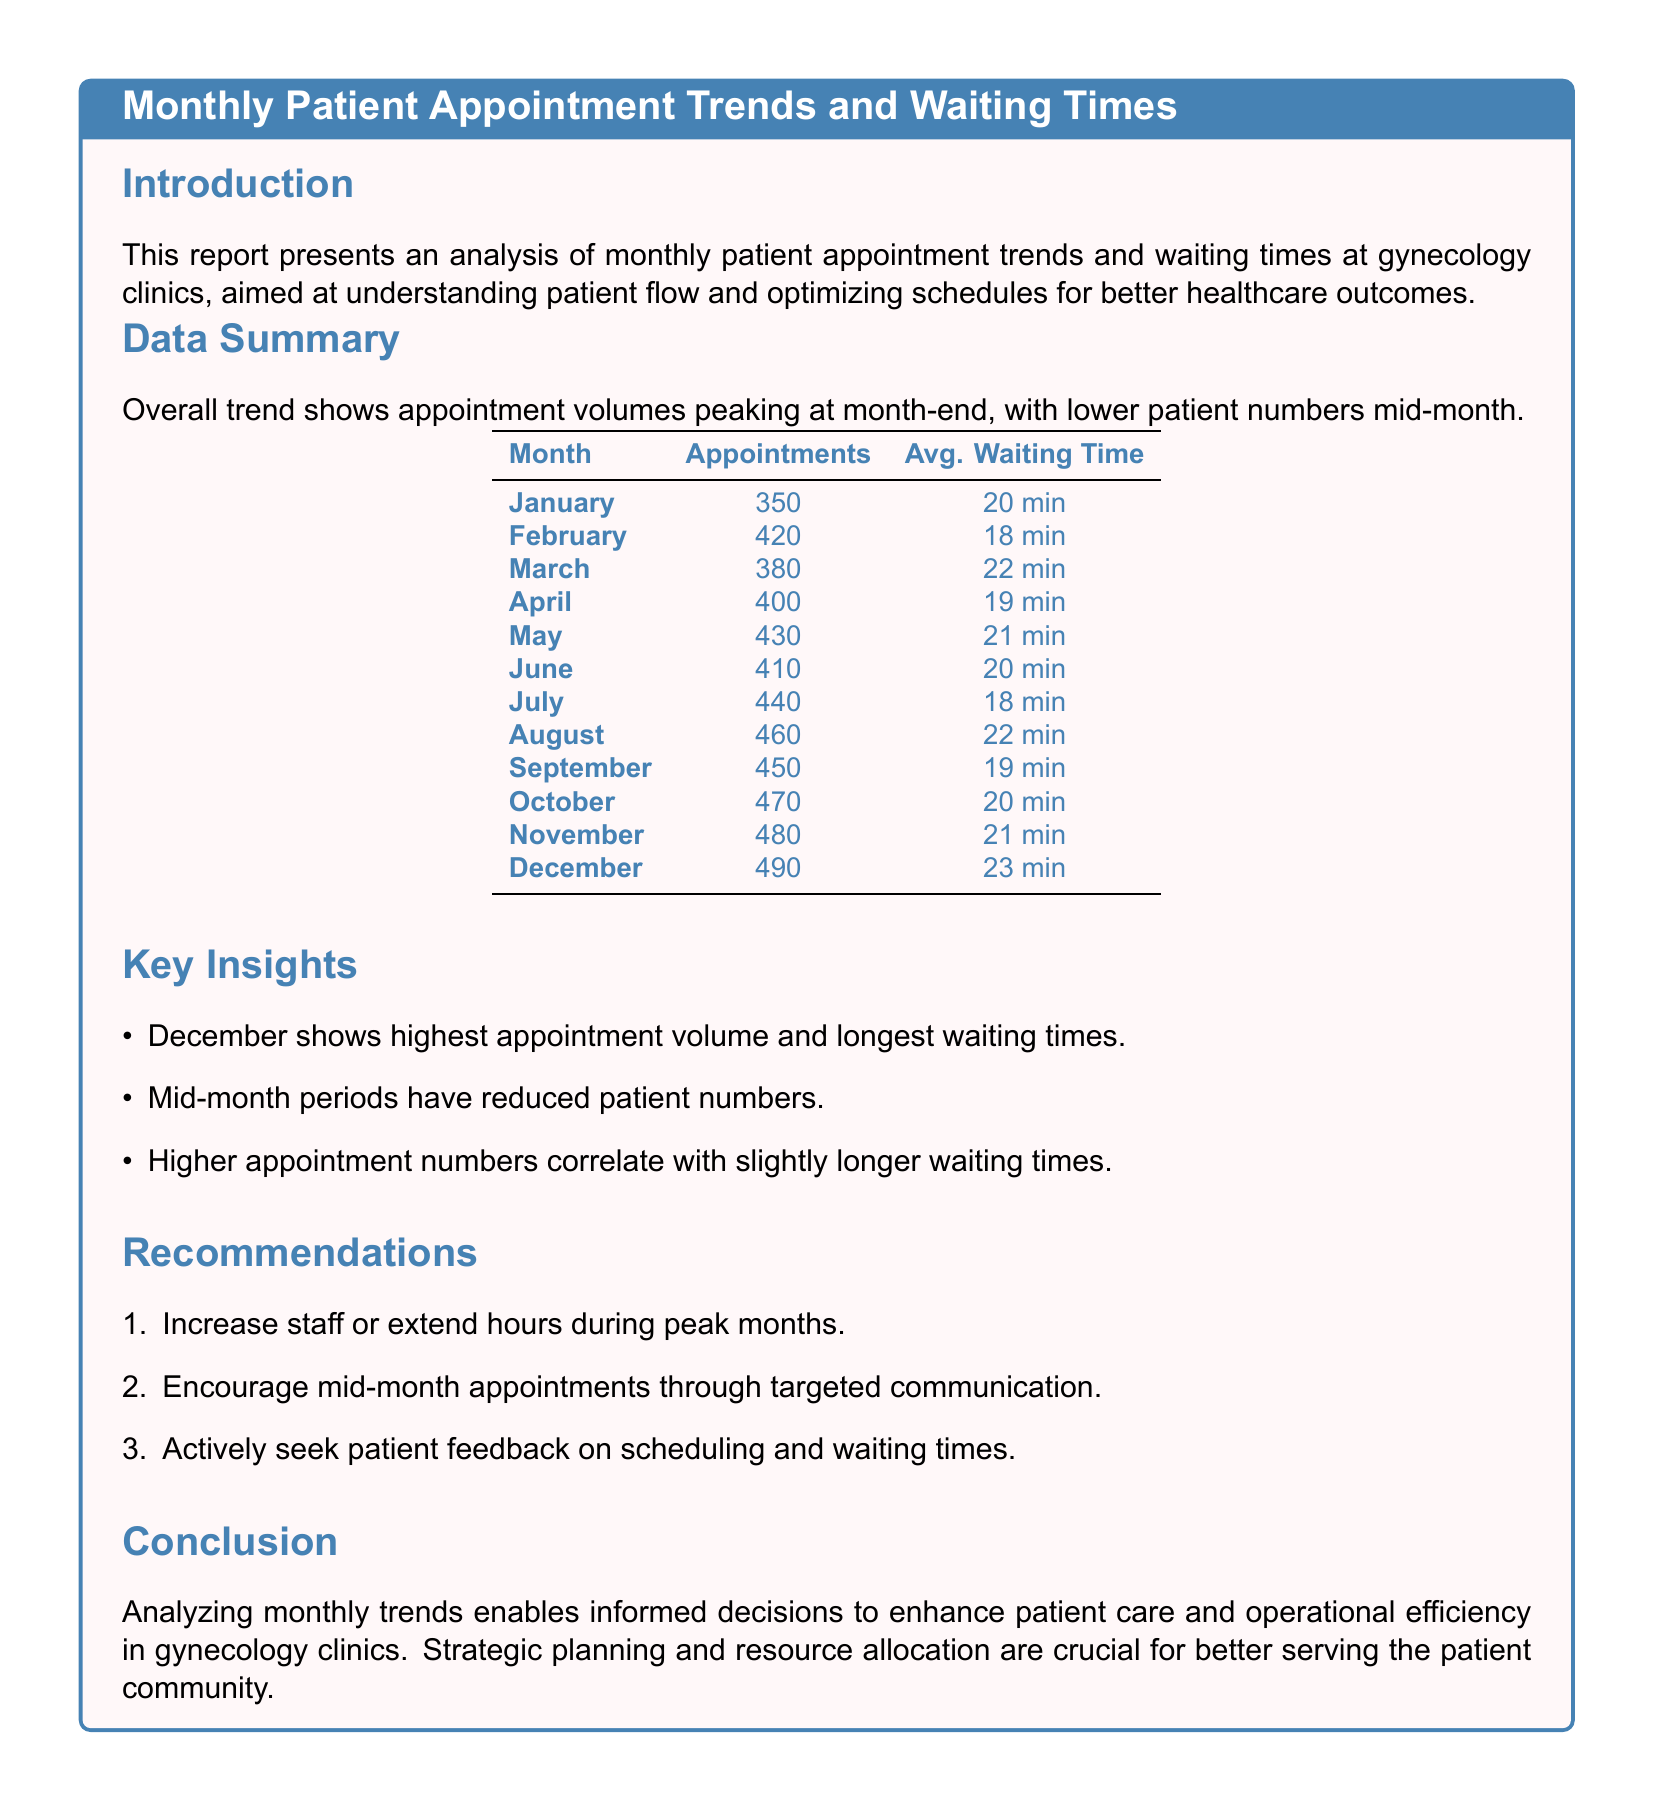What is the highest number of appointments recorded? The highest number of appointments recorded is found in the summary table for December, where it equals 490.
Answer: 490 What is the average waiting time in January? The average waiting time for January is specifically listed in the data summary section as 20 minutes.
Answer: 20 min Which month has the lowest average waiting time? By comparing the average waiting times across all months in the table, February has the lowest average waiting time of 18 minutes.
Answer: 18 min What is the total number of appointments in May? The total number of appointments for May is explicitly stated in the table as 430.
Answer: 430 What trend is observed regarding appointment volumes? The overall trend indicates a peak in appointment volumes at the end of each month, as mentioned in the introduction.
Answer: Peaks at month-end How do waiting times correlate with appointment numbers according to the report? The report suggests that higher appointment numbers correlate with slightly longer waiting times, indicating a relationship.
Answer: Slightly longer waiting times What is one recommendation made to improve patient flow? One recommendation from the report is to encourage mid-month appointments through targeted communication.
Answer: Encourage mid-month appointments Which month has the longest waiting time? Upon examining the data, December is identified as the month with the longest average waiting time of 23 minutes.
Answer: 23 min What does the report suggest regarding staff during peak months? The report advises to increase staff or extend hours during peak months for better management of appointment volumes.
Answer: Increase staff or extend hours 